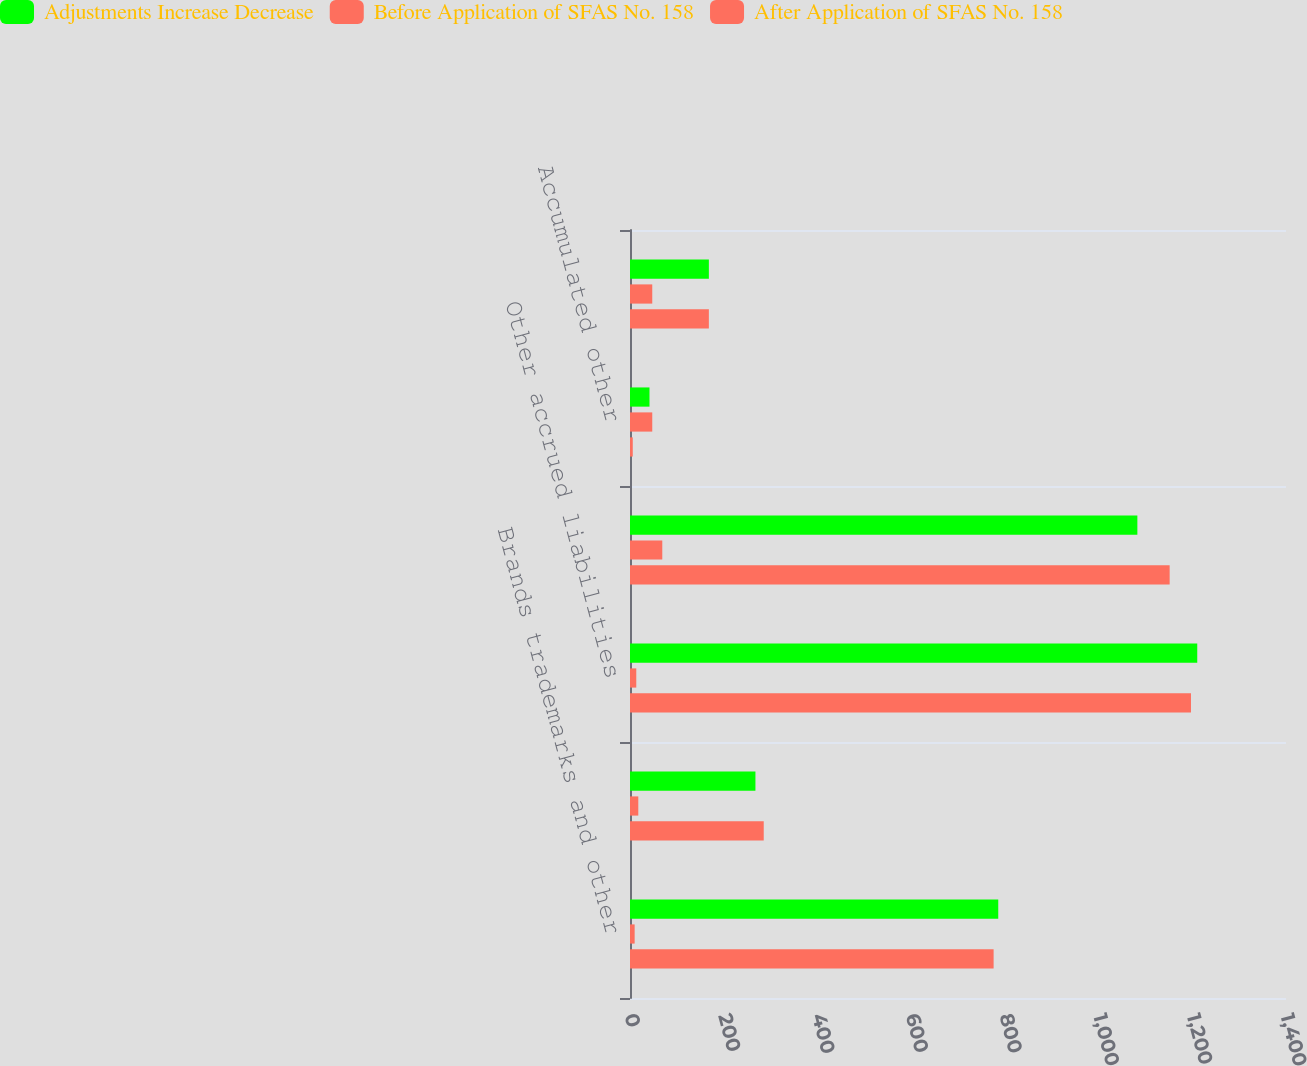Convert chart to OTSL. <chart><loc_0><loc_0><loc_500><loc_500><stacked_bar_chart><ecel><fcel>Brands trademarks and other<fcel>Other assets<fcel>Other accrued liabilities<fcel>Other noncurrent liabilities<fcel>Accumulated other<fcel>Total common stockholders'<nl><fcel>Adjustments Increase Decrease<fcel>785.9<fcel>267.7<fcel>1210.6<fcel>1082.8<fcel>41.6<fcel>168.3<nl><fcel>Before Application of SFAS No. 158<fcel>9.9<fcel>17.7<fcel>13.4<fcel>68.9<fcel>47.5<fcel>47.5<nl><fcel>After Application of SFAS No. 158<fcel>776<fcel>285.4<fcel>1197.2<fcel>1151.7<fcel>5.9<fcel>168.3<nl></chart> 